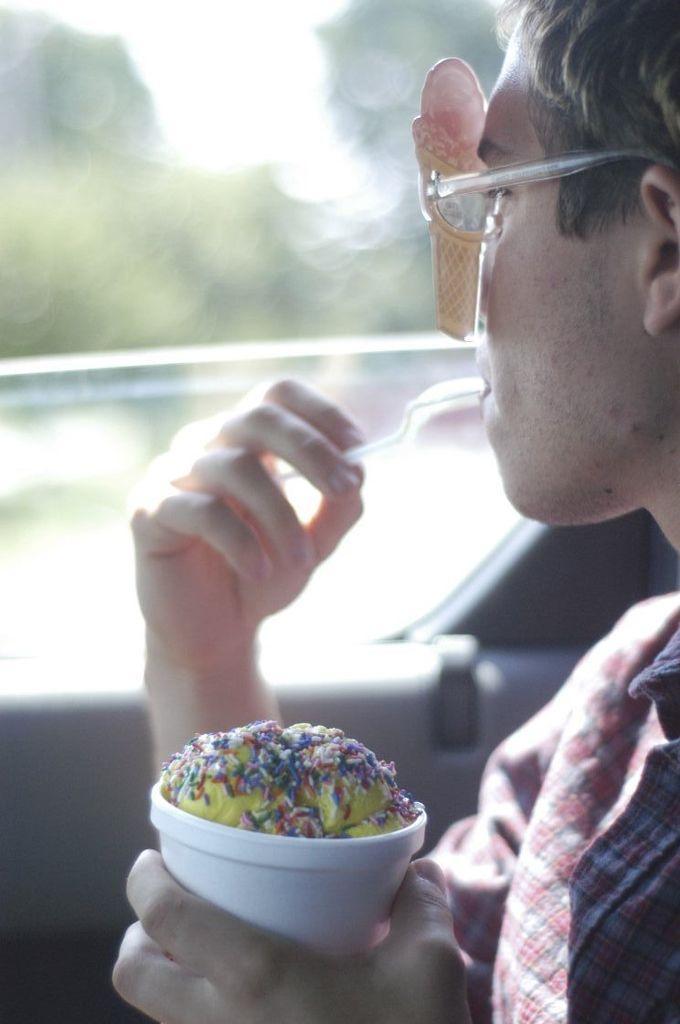How would you summarize this image in a sentence or two? In this picture we can see a man, he is seated and he wore spectacles, and he is holding a cup in his hand, in the background we can see few trees. 